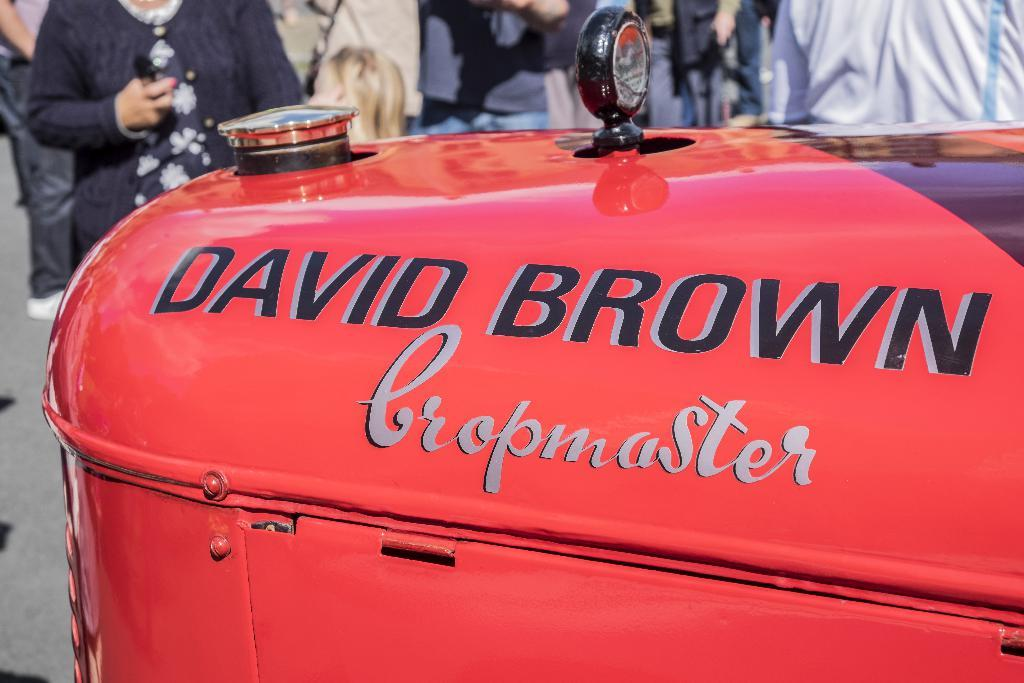What is the color of the fuel tank in the image? The fuel tank in the image is red. What can be seen on the fuel tank? Something is written on the fuel tank. What is happening in the background of the image? There is a group of people in the background of the image. How can you describe the appearance of the people in the background? The people in the background are wearing different color dresses. What type of drink is being served from the fuel tank in the image? The fuel tank in the image is not serving any drink; it is a fuel tank for vehicles. 